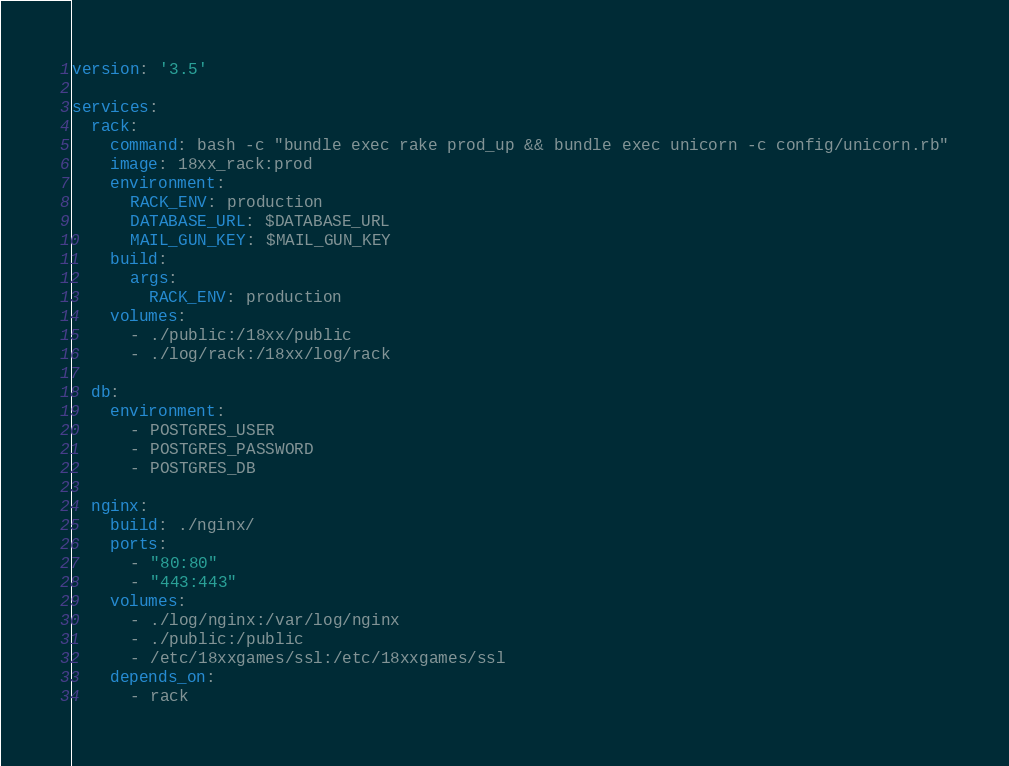Convert code to text. <code><loc_0><loc_0><loc_500><loc_500><_YAML_>version: '3.5'

services:
  rack:
    command: bash -c "bundle exec rake prod_up && bundle exec unicorn -c config/unicorn.rb"
    image: 18xx_rack:prod
    environment:
      RACK_ENV: production
      DATABASE_URL: $DATABASE_URL
      MAIL_GUN_KEY: $MAIL_GUN_KEY
    build:
      args:
        RACK_ENV: production
    volumes:
      - ./public:/18xx/public
      - ./log/rack:/18xx/log/rack

  db:
    environment:
      - POSTGRES_USER
      - POSTGRES_PASSWORD
      - POSTGRES_DB

  nginx:
    build: ./nginx/
    ports:
      - "80:80"
      - "443:443"
    volumes:
      - ./log/nginx:/var/log/nginx
      - ./public:/public
      - /etc/18xxgames/ssl:/etc/18xxgames/ssl
    depends_on:
      - rack
</code> 